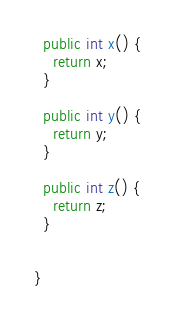<code> <loc_0><loc_0><loc_500><loc_500><_Java_>
  public int x() {
    return x;
  }

  public int y() {
    return y;
  }

  public int z() {
    return z;
  }


}
</code> 